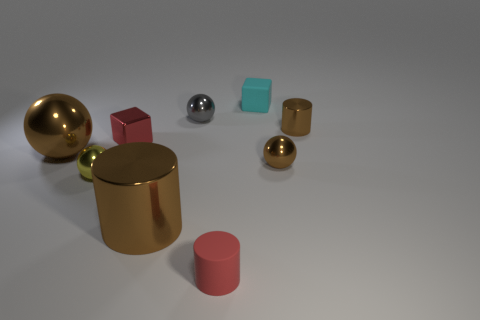Subtract all cylinders. How many objects are left? 6 Subtract 0 blue cubes. How many objects are left? 9 Subtract all metallic spheres. Subtract all large cyan cubes. How many objects are left? 5 Add 6 large shiny cylinders. How many large shiny cylinders are left? 7 Add 1 small brown cylinders. How many small brown cylinders exist? 2 